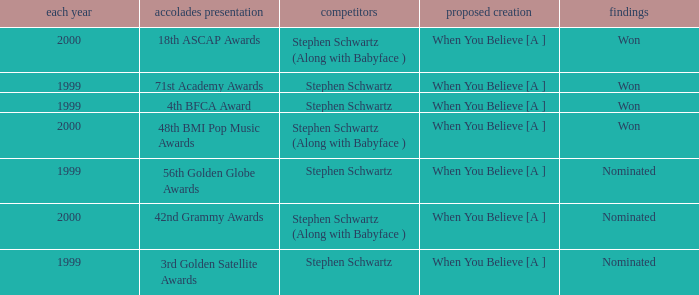Write the full table. {'header': ['each year', 'accolades presentation', 'competitors', 'proposed creation', 'findings'], 'rows': [['2000', '18th ASCAP Awards', 'Stephen Schwartz (Along with Babyface )', 'When You Believe [A ]', 'Won'], ['1999', '71st Academy Awards', 'Stephen Schwartz', 'When You Believe [A ]', 'Won'], ['1999', '4th BFCA Award', 'Stephen Schwartz', 'When You Believe [A ]', 'Won'], ['2000', '48th BMI Pop Music Awards', 'Stephen Schwartz (Along with Babyface )', 'When You Believe [A ]', 'Won'], ['1999', '56th Golden Globe Awards', 'Stephen Schwartz', 'When You Believe [A ]', 'Nominated'], ['2000', '42nd Grammy Awards', 'Stephen Schwartz (Along with Babyface )', 'When You Believe [A ]', 'Nominated'], ['1999', '3rd Golden Satellite Awards', 'Stephen Schwartz', 'When You Believe [A ]', 'Nominated']]} What was the result in 2000? Won, Won, Nominated. 